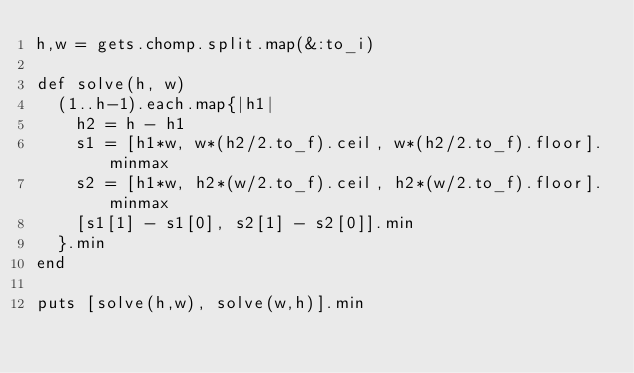<code> <loc_0><loc_0><loc_500><loc_500><_Ruby_>h,w = gets.chomp.split.map(&:to_i)

def solve(h, w)
  (1..h-1).each.map{|h1|
    h2 = h - h1
    s1 = [h1*w, w*(h2/2.to_f).ceil, w*(h2/2.to_f).floor].minmax
    s2 = [h1*w, h2*(w/2.to_f).ceil, h2*(w/2.to_f).floor].minmax
    [s1[1] - s1[0], s2[1] - s2[0]].min
  }.min
end

puts [solve(h,w), solve(w,h)].min</code> 